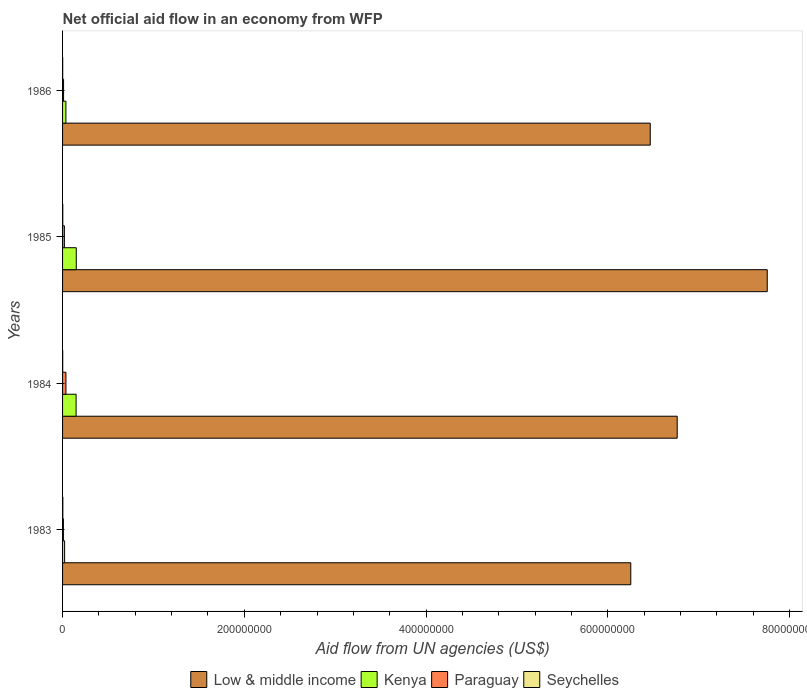How many groups of bars are there?
Provide a short and direct response. 4. Are the number of bars on each tick of the Y-axis equal?
Your answer should be compact. Yes. How many bars are there on the 4th tick from the top?
Keep it short and to the point. 4. In how many cases, is the number of bars for a given year not equal to the number of legend labels?
Give a very brief answer. 0. What is the net official aid flow in Low & middle income in 1985?
Provide a short and direct response. 7.75e+08. Across all years, what is the maximum net official aid flow in Low & middle income?
Your answer should be compact. 7.75e+08. Across all years, what is the minimum net official aid flow in Kenya?
Provide a succinct answer. 2.24e+06. In which year was the net official aid flow in Paraguay minimum?
Make the answer very short. 1983. What is the total net official aid flow in Paraguay in the graph?
Your response must be concise. 7.72e+06. What is the difference between the net official aid flow in Kenya in 1983 and that in 1986?
Provide a succinct answer. -1.43e+06. What is the difference between the net official aid flow in Paraguay in 1985 and the net official aid flow in Kenya in 1986?
Offer a very short reply. -1.67e+06. What is the average net official aid flow in Seychelles per year?
Give a very brief answer. 2.02e+05. In the year 1986, what is the difference between the net official aid flow in Paraguay and net official aid flow in Kenya?
Your response must be concise. -2.58e+06. In how many years, is the net official aid flow in Paraguay greater than 520000000 US$?
Make the answer very short. 0. What is the ratio of the net official aid flow in Low & middle income in 1984 to that in 1986?
Offer a very short reply. 1.05. Is the net official aid flow in Paraguay in 1983 less than that in 1984?
Your answer should be very brief. Yes. What is the difference between the highest and the second highest net official aid flow in Paraguay?
Your answer should be very brief. 1.71e+06. What is the difference between the highest and the lowest net official aid flow in Kenya?
Offer a terse response. 1.28e+07. Is the sum of the net official aid flow in Kenya in 1985 and 1986 greater than the maximum net official aid flow in Low & middle income across all years?
Provide a succinct answer. No. Is it the case that in every year, the sum of the net official aid flow in Paraguay and net official aid flow in Kenya is greater than the sum of net official aid flow in Seychelles and net official aid flow in Low & middle income?
Keep it short and to the point. No. What does the 1st bar from the top in 1983 represents?
Make the answer very short. Seychelles. What does the 1st bar from the bottom in 1983 represents?
Offer a terse response. Low & middle income. Are all the bars in the graph horizontal?
Make the answer very short. Yes. Are the values on the major ticks of X-axis written in scientific E-notation?
Provide a short and direct response. No. What is the title of the graph?
Make the answer very short. Net official aid flow in an economy from WFP. What is the label or title of the X-axis?
Keep it short and to the point. Aid flow from UN agencies (US$). What is the label or title of the Y-axis?
Offer a terse response. Years. What is the Aid flow from UN agencies (US$) in Low & middle income in 1983?
Your response must be concise. 6.25e+08. What is the Aid flow from UN agencies (US$) of Kenya in 1983?
Offer a terse response. 2.24e+06. What is the Aid flow from UN agencies (US$) of Paraguay in 1983?
Make the answer very short. 9.20e+05. What is the Aid flow from UN agencies (US$) in Seychelles in 1983?
Your answer should be very brief. 2.80e+05. What is the Aid flow from UN agencies (US$) in Low & middle income in 1984?
Ensure brevity in your answer.  6.76e+08. What is the Aid flow from UN agencies (US$) in Kenya in 1984?
Make the answer very short. 1.49e+07. What is the Aid flow from UN agencies (US$) in Paraguay in 1984?
Offer a terse response. 3.71e+06. What is the Aid flow from UN agencies (US$) of Low & middle income in 1985?
Ensure brevity in your answer.  7.75e+08. What is the Aid flow from UN agencies (US$) in Kenya in 1985?
Provide a short and direct response. 1.51e+07. What is the Aid flow from UN agencies (US$) of Low & middle income in 1986?
Your answer should be very brief. 6.47e+08. What is the Aid flow from UN agencies (US$) in Kenya in 1986?
Provide a short and direct response. 3.67e+06. What is the Aid flow from UN agencies (US$) of Paraguay in 1986?
Offer a very short reply. 1.09e+06. What is the Aid flow from UN agencies (US$) in Seychelles in 1986?
Your response must be concise. 1.40e+05. Across all years, what is the maximum Aid flow from UN agencies (US$) in Low & middle income?
Offer a very short reply. 7.75e+08. Across all years, what is the maximum Aid flow from UN agencies (US$) in Kenya?
Your answer should be compact. 1.51e+07. Across all years, what is the maximum Aid flow from UN agencies (US$) of Paraguay?
Provide a short and direct response. 3.71e+06. Across all years, what is the minimum Aid flow from UN agencies (US$) in Low & middle income?
Your answer should be compact. 6.25e+08. Across all years, what is the minimum Aid flow from UN agencies (US$) in Kenya?
Make the answer very short. 2.24e+06. Across all years, what is the minimum Aid flow from UN agencies (US$) of Paraguay?
Provide a succinct answer. 9.20e+05. What is the total Aid flow from UN agencies (US$) in Low & middle income in the graph?
Give a very brief answer. 2.72e+09. What is the total Aid flow from UN agencies (US$) in Kenya in the graph?
Your answer should be compact. 3.59e+07. What is the total Aid flow from UN agencies (US$) in Paraguay in the graph?
Your answer should be compact. 7.72e+06. What is the total Aid flow from UN agencies (US$) in Seychelles in the graph?
Your answer should be very brief. 8.10e+05. What is the difference between the Aid flow from UN agencies (US$) of Low & middle income in 1983 and that in 1984?
Ensure brevity in your answer.  -5.11e+07. What is the difference between the Aid flow from UN agencies (US$) of Kenya in 1983 and that in 1984?
Provide a succinct answer. -1.27e+07. What is the difference between the Aid flow from UN agencies (US$) in Paraguay in 1983 and that in 1984?
Offer a very short reply. -2.79e+06. What is the difference between the Aid flow from UN agencies (US$) of Seychelles in 1983 and that in 1984?
Your response must be concise. 1.10e+05. What is the difference between the Aid flow from UN agencies (US$) of Low & middle income in 1983 and that in 1985?
Your response must be concise. -1.50e+08. What is the difference between the Aid flow from UN agencies (US$) in Kenya in 1983 and that in 1985?
Your answer should be very brief. -1.28e+07. What is the difference between the Aid flow from UN agencies (US$) in Paraguay in 1983 and that in 1985?
Your response must be concise. -1.08e+06. What is the difference between the Aid flow from UN agencies (US$) of Seychelles in 1983 and that in 1985?
Keep it short and to the point. 6.00e+04. What is the difference between the Aid flow from UN agencies (US$) in Low & middle income in 1983 and that in 1986?
Provide a short and direct response. -2.14e+07. What is the difference between the Aid flow from UN agencies (US$) in Kenya in 1983 and that in 1986?
Provide a succinct answer. -1.43e+06. What is the difference between the Aid flow from UN agencies (US$) in Paraguay in 1983 and that in 1986?
Provide a short and direct response. -1.70e+05. What is the difference between the Aid flow from UN agencies (US$) of Seychelles in 1983 and that in 1986?
Make the answer very short. 1.40e+05. What is the difference between the Aid flow from UN agencies (US$) of Low & middle income in 1984 and that in 1985?
Keep it short and to the point. -9.91e+07. What is the difference between the Aid flow from UN agencies (US$) in Kenya in 1984 and that in 1985?
Ensure brevity in your answer.  -1.70e+05. What is the difference between the Aid flow from UN agencies (US$) in Paraguay in 1984 and that in 1985?
Ensure brevity in your answer.  1.71e+06. What is the difference between the Aid flow from UN agencies (US$) of Seychelles in 1984 and that in 1985?
Provide a short and direct response. -5.00e+04. What is the difference between the Aid flow from UN agencies (US$) in Low & middle income in 1984 and that in 1986?
Offer a terse response. 2.97e+07. What is the difference between the Aid flow from UN agencies (US$) in Kenya in 1984 and that in 1986?
Ensure brevity in your answer.  1.12e+07. What is the difference between the Aid flow from UN agencies (US$) of Paraguay in 1984 and that in 1986?
Keep it short and to the point. 2.62e+06. What is the difference between the Aid flow from UN agencies (US$) in Low & middle income in 1985 and that in 1986?
Offer a terse response. 1.29e+08. What is the difference between the Aid flow from UN agencies (US$) of Kenya in 1985 and that in 1986?
Provide a succinct answer. 1.14e+07. What is the difference between the Aid flow from UN agencies (US$) of Paraguay in 1985 and that in 1986?
Ensure brevity in your answer.  9.10e+05. What is the difference between the Aid flow from UN agencies (US$) in Low & middle income in 1983 and the Aid flow from UN agencies (US$) in Kenya in 1984?
Your answer should be very brief. 6.10e+08. What is the difference between the Aid flow from UN agencies (US$) in Low & middle income in 1983 and the Aid flow from UN agencies (US$) in Paraguay in 1984?
Your answer should be compact. 6.22e+08. What is the difference between the Aid flow from UN agencies (US$) in Low & middle income in 1983 and the Aid flow from UN agencies (US$) in Seychelles in 1984?
Your response must be concise. 6.25e+08. What is the difference between the Aid flow from UN agencies (US$) of Kenya in 1983 and the Aid flow from UN agencies (US$) of Paraguay in 1984?
Provide a short and direct response. -1.47e+06. What is the difference between the Aid flow from UN agencies (US$) in Kenya in 1983 and the Aid flow from UN agencies (US$) in Seychelles in 1984?
Your answer should be very brief. 2.07e+06. What is the difference between the Aid flow from UN agencies (US$) of Paraguay in 1983 and the Aid flow from UN agencies (US$) of Seychelles in 1984?
Your answer should be very brief. 7.50e+05. What is the difference between the Aid flow from UN agencies (US$) in Low & middle income in 1983 and the Aid flow from UN agencies (US$) in Kenya in 1985?
Offer a very short reply. 6.10e+08. What is the difference between the Aid flow from UN agencies (US$) of Low & middle income in 1983 and the Aid flow from UN agencies (US$) of Paraguay in 1985?
Offer a very short reply. 6.23e+08. What is the difference between the Aid flow from UN agencies (US$) of Low & middle income in 1983 and the Aid flow from UN agencies (US$) of Seychelles in 1985?
Your answer should be compact. 6.25e+08. What is the difference between the Aid flow from UN agencies (US$) of Kenya in 1983 and the Aid flow from UN agencies (US$) of Paraguay in 1985?
Your answer should be compact. 2.40e+05. What is the difference between the Aid flow from UN agencies (US$) of Kenya in 1983 and the Aid flow from UN agencies (US$) of Seychelles in 1985?
Your answer should be compact. 2.02e+06. What is the difference between the Aid flow from UN agencies (US$) of Low & middle income in 1983 and the Aid flow from UN agencies (US$) of Kenya in 1986?
Provide a short and direct response. 6.22e+08. What is the difference between the Aid flow from UN agencies (US$) in Low & middle income in 1983 and the Aid flow from UN agencies (US$) in Paraguay in 1986?
Keep it short and to the point. 6.24e+08. What is the difference between the Aid flow from UN agencies (US$) in Low & middle income in 1983 and the Aid flow from UN agencies (US$) in Seychelles in 1986?
Your answer should be very brief. 6.25e+08. What is the difference between the Aid flow from UN agencies (US$) of Kenya in 1983 and the Aid flow from UN agencies (US$) of Paraguay in 1986?
Your answer should be compact. 1.15e+06. What is the difference between the Aid flow from UN agencies (US$) of Kenya in 1983 and the Aid flow from UN agencies (US$) of Seychelles in 1986?
Provide a succinct answer. 2.10e+06. What is the difference between the Aid flow from UN agencies (US$) of Paraguay in 1983 and the Aid flow from UN agencies (US$) of Seychelles in 1986?
Keep it short and to the point. 7.80e+05. What is the difference between the Aid flow from UN agencies (US$) of Low & middle income in 1984 and the Aid flow from UN agencies (US$) of Kenya in 1985?
Make the answer very short. 6.61e+08. What is the difference between the Aid flow from UN agencies (US$) of Low & middle income in 1984 and the Aid flow from UN agencies (US$) of Paraguay in 1985?
Keep it short and to the point. 6.74e+08. What is the difference between the Aid flow from UN agencies (US$) of Low & middle income in 1984 and the Aid flow from UN agencies (US$) of Seychelles in 1985?
Keep it short and to the point. 6.76e+08. What is the difference between the Aid flow from UN agencies (US$) of Kenya in 1984 and the Aid flow from UN agencies (US$) of Paraguay in 1985?
Your response must be concise. 1.29e+07. What is the difference between the Aid flow from UN agencies (US$) in Kenya in 1984 and the Aid flow from UN agencies (US$) in Seychelles in 1985?
Your response must be concise. 1.47e+07. What is the difference between the Aid flow from UN agencies (US$) of Paraguay in 1984 and the Aid flow from UN agencies (US$) of Seychelles in 1985?
Offer a very short reply. 3.49e+06. What is the difference between the Aid flow from UN agencies (US$) in Low & middle income in 1984 and the Aid flow from UN agencies (US$) in Kenya in 1986?
Your answer should be very brief. 6.73e+08. What is the difference between the Aid flow from UN agencies (US$) in Low & middle income in 1984 and the Aid flow from UN agencies (US$) in Paraguay in 1986?
Your answer should be very brief. 6.75e+08. What is the difference between the Aid flow from UN agencies (US$) of Low & middle income in 1984 and the Aid flow from UN agencies (US$) of Seychelles in 1986?
Ensure brevity in your answer.  6.76e+08. What is the difference between the Aid flow from UN agencies (US$) of Kenya in 1984 and the Aid flow from UN agencies (US$) of Paraguay in 1986?
Provide a short and direct response. 1.38e+07. What is the difference between the Aid flow from UN agencies (US$) in Kenya in 1984 and the Aid flow from UN agencies (US$) in Seychelles in 1986?
Your answer should be compact. 1.48e+07. What is the difference between the Aid flow from UN agencies (US$) of Paraguay in 1984 and the Aid flow from UN agencies (US$) of Seychelles in 1986?
Give a very brief answer. 3.57e+06. What is the difference between the Aid flow from UN agencies (US$) in Low & middle income in 1985 and the Aid flow from UN agencies (US$) in Kenya in 1986?
Offer a terse response. 7.72e+08. What is the difference between the Aid flow from UN agencies (US$) in Low & middle income in 1985 and the Aid flow from UN agencies (US$) in Paraguay in 1986?
Give a very brief answer. 7.74e+08. What is the difference between the Aid flow from UN agencies (US$) of Low & middle income in 1985 and the Aid flow from UN agencies (US$) of Seychelles in 1986?
Offer a very short reply. 7.75e+08. What is the difference between the Aid flow from UN agencies (US$) of Kenya in 1985 and the Aid flow from UN agencies (US$) of Paraguay in 1986?
Provide a succinct answer. 1.40e+07. What is the difference between the Aid flow from UN agencies (US$) in Kenya in 1985 and the Aid flow from UN agencies (US$) in Seychelles in 1986?
Make the answer very short. 1.49e+07. What is the difference between the Aid flow from UN agencies (US$) of Paraguay in 1985 and the Aid flow from UN agencies (US$) of Seychelles in 1986?
Offer a terse response. 1.86e+06. What is the average Aid flow from UN agencies (US$) in Low & middle income per year?
Offer a terse response. 6.81e+08. What is the average Aid flow from UN agencies (US$) of Kenya per year?
Keep it short and to the point. 8.97e+06. What is the average Aid flow from UN agencies (US$) of Paraguay per year?
Your response must be concise. 1.93e+06. What is the average Aid flow from UN agencies (US$) of Seychelles per year?
Offer a very short reply. 2.02e+05. In the year 1983, what is the difference between the Aid flow from UN agencies (US$) in Low & middle income and Aid flow from UN agencies (US$) in Kenya?
Your answer should be compact. 6.23e+08. In the year 1983, what is the difference between the Aid flow from UN agencies (US$) in Low & middle income and Aid flow from UN agencies (US$) in Paraguay?
Provide a succinct answer. 6.24e+08. In the year 1983, what is the difference between the Aid flow from UN agencies (US$) of Low & middle income and Aid flow from UN agencies (US$) of Seychelles?
Provide a succinct answer. 6.25e+08. In the year 1983, what is the difference between the Aid flow from UN agencies (US$) in Kenya and Aid flow from UN agencies (US$) in Paraguay?
Provide a succinct answer. 1.32e+06. In the year 1983, what is the difference between the Aid flow from UN agencies (US$) in Kenya and Aid flow from UN agencies (US$) in Seychelles?
Your response must be concise. 1.96e+06. In the year 1983, what is the difference between the Aid flow from UN agencies (US$) of Paraguay and Aid flow from UN agencies (US$) of Seychelles?
Keep it short and to the point. 6.40e+05. In the year 1984, what is the difference between the Aid flow from UN agencies (US$) of Low & middle income and Aid flow from UN agencies (US$) of Kenya?
Keep it short and to the point. 6.61e+08. In the year 1984, what is the difference between the Aid flow from UN agencies (US$) in Low & middle income and Aid flow from UN agencies (US$) in Paraguay?
Ensure brevity in your answer.  6.73e+08. In the year 1984, what is the difference between the Aid flow from UN agencies (US$) of Low & middle income and Aid flow from UN agencies (US$) of Seychelles?
Offer a terse response. 6.76e+08. In the year 1984, what is the difference between the Aid flow from UN agencies (US$) of Kenya and Aid flow from UN agencies (US$) of Paraguay?
Give a very brief answer. 1.12e+07. In the year 1984, what is the difference between the Aid flow from UN agencies (US$) in Kenya and Aid flow from UN agencies (US$) in Seychelles?
Offer a very short reply. 1.47e+07. In the year 1984, what is the difference between the Aid flow from UN agencies (US$) in Paraguay and Aid flow from UN agencies (US$) in Seychelles?
Keep it short and to the point. 3.54e+06. In the year 1985, what is the difference between the Aid flow from UN agencies (US$) in Low & middle income and Aid flow from UN agencies (US$) in Kenya?
Ensure brevity in your answer.  7.60e+08. In the year 1985, what is the difference between the Aid flow from UN agencies (US$) in Low & middle income and Aid flow from UN agencies (US$) in Paraguay?
Provide a short and direct response. 7.73e+08. In the year 1985, what is the difference between the Aid flow from UN agencies (US$) of Low & middle income and Aid flow from UN agencies (US$) of Seychelles?
Make the answer very short. 7.75e+08. In the year 1985, what is the difference between the Aid flow from UN agencies (US$) of Kenya and Aid flow from UN agencies (US$) of Paraguay?
Offer a very short reply. 1.31e+07. In the year 1985, what is the difference between the Aid flow from UN agencies (US$) in Kenya and Aid flow from UN agencies (US$) in Seychelles?
Offer a very short reply. 1.48e+07. In the year 1985, what is the difference between the Aid flow from UN agencies (US$) of Paraguay and Aid flow from UN agencies (US$) of Seychelles?
Ensure brevity in your answer.  1.78e+06. In the year 1986, what is the difference between the Aid flow from UN agencies (US$) of Low & middle income and Aid flow from UN agencies (US$) of Kenya?
Provide a succinct answer. 6.43e+08. In the year 1986, what is the difference between the Aid flow from UN agencies (US$) of Low & middle income and Aid flow from UN agencies (US$) of Paraguay?
Offer a very short reply. 6.46e+08. In the year 1986, what is the difference between the Aid flow from UN agencies (US$) of Low & middle income and Aid flow from UN agencies (US$) of Seychelles?
Offer a terse response. 6.47e+08. In the year 1986, what is the difference between the Aid flow from UN agencies (US$) in Kenya and Aid flow from UN agencies (US$) in Paraguay?
Provide a short and direct response. 2.58e+06. In the year 1986, what is the difference between the Aid flow from UN agencies (US$) in Kenya and Aid flow from UN agencies (US$) in Seychelles?
Provide a short and direct response. 3.53e+06. In the year 1986, what is the difference between the Aid flow from UN agencies (US$) in Paraguay and Aid flow from UN agencies (US$) in Seychelles?
Your answer should be very brief. 9.50e+05. What is the ratio of the Aid flow from UN agencies (US$) in Low & middle income in 1983 to that in 1984?
Give a very brief answer. 0.92. What is the ratio of the Aid flow from UN agencies (US$) in Kenya in 1983 to that in 1984?
Your response must be concise. 0.15. What is the ratio of the Aid flow from UN agencies (US$) of Paraguay in 1983 to that in 1984?
Make the answer very short. 0.25. What is the ratio of the Aid flow from UN agencies (US$) of Seychelles in 1983 to that in 1984?
Your response must be concise. 1.65. What is the ratio of the Aid flow from UN agencies (US$) in Low & middle income in 1983 to that in 1985?
Your answer should be compact. 0.81. What is the ratio of the Aid flow from UN agencies (US$) in Kenya in 1983 to that in 1985?
Give a very brief answer. 0.15. What is the ratio of the Aid flow from UN agencies (US$) in Paraguay in 1983 to that in 1985?
Keep it short and to the point. 0.46. What is the ratio of the Aid flow from UN agencies (US$) of Seychelles in 1983 to that in 1985?
Provide a short and direct response. 1.27. What is the ratio of the Aid flow from UN agencies (US$) of Low & middle income in 1983 to that in 1986?
Give a very brief answer. 0.97. What is the ratio of the Aid flow from UN agencies (US$) in Kenya in 1983 to that in 1986?
Your answer should be compact. 0.61. What is the ratio of the Aid flow from UN agencies (US$) in Paraguay in 1983 to that in 1986?
Your answer should be compact. 0.84. What is the ratio of the Aid flow from UN agencies (US$) of Low & middle income in 1984 to that in 1985?
Provide a succinct answer. 0.87. What is the ratio of the Aid flow from UN agencies (US$) in Kenya in 1984 to that in 1985?
Provide a succinct answer. 0.99. What is the ratio of the Aid flow from UN agencies (US$) of Paraguay in 1984 to that in 1985?
Your response must be concise. 1.85. What is the ratio of the Aid flow from UN agencies (US$) in Seychelles in 1984 to that in 1985?
Your answer should be very brief. 0.77. What is the ratio of the Aid flow from UN agencies (US$) in Low & middle income in 1984 to that in 1986?
Your response must be concise. 1.05. What is the ratio of the Aid flow from UN agencies (US$) in Kenya in 1984 to that in 1986?
Your response must be concise. 4.06. What is the ratio of the Aid flow from UN agencies (US$) of Paraguay in 1984 to that in 1986?
Provide a succinct answer. 3.4. What is the ratio of the Aid flow from UN agencies (US$) in Seychelles in 1984 to that in 1986?
Offer a very short reply. 1.21. What is the ratio of the Aid flow from UN agencies (US$) of Low & middle income in 1985 to that in 1986?
Give a very brief answer. 1.2. What is the ratio of the Aid flow from UN agencies (US$) of Kenya in 1985 to that in 1986?
Provide a succinct answer. 4.11. What is the ratio of the Aid flow from UN agencies (US$) of Paraguay in 1985 to that in 1986?
Your response must be concise. 1.83. What is the ratio of the Aid flow from UN agencies (US$) in Seychelles in 1985 to that in 1986?
Provide a succinct answer. 1.57. What is the difference between the highest and the second highest Aid flow from UN agencies (US$) in Low & middle income?
Provide a short and direct response. 9.91e+07. What is the difference between the highest and the second highest Aid flow from UN agencies (US$) in Kenya?
Provide a short and direct response. 1.70e+05. What is the difference between the highest and the second highest Aid flow from UN agencies (US$) of Paraguay?
Keep it short and to the point. 1.71e+06. What is the difference between the highest and the second highest Aid flow from UN agencies (US$) in Seychelles?
Keep it short and to the point. 6.00e+04. What is the difference between the highest and the lowest Aid flow from UN agencies (US$) in Low & middle income?
Give a very brief answer. 1.50e+08. What is the difference between the highest and the lowest Aid flow from UN agencies (US$) of Kenya?
Offer a very short reply. 1.28e+07. What is the difference between the highest and the lowest Aid flow from UN agencies (US$) in Paraguay?
Your response must be concise. 2.79e+06. 